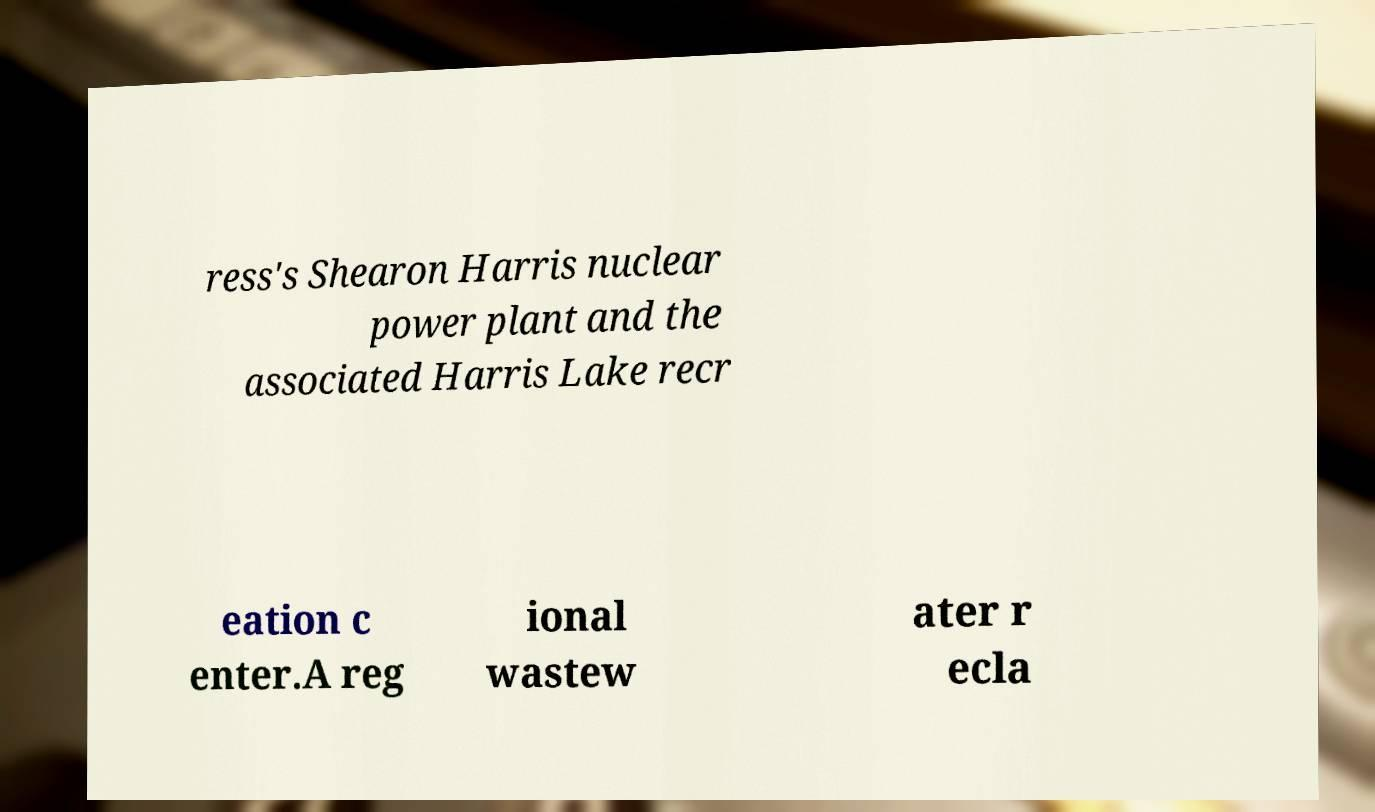Please identify and transcribe the text found in this image. ress's Shearon Harris nuclear power plant and the associated Harris Lake recr eation c enter.A reg ional wastew ater r ecla 